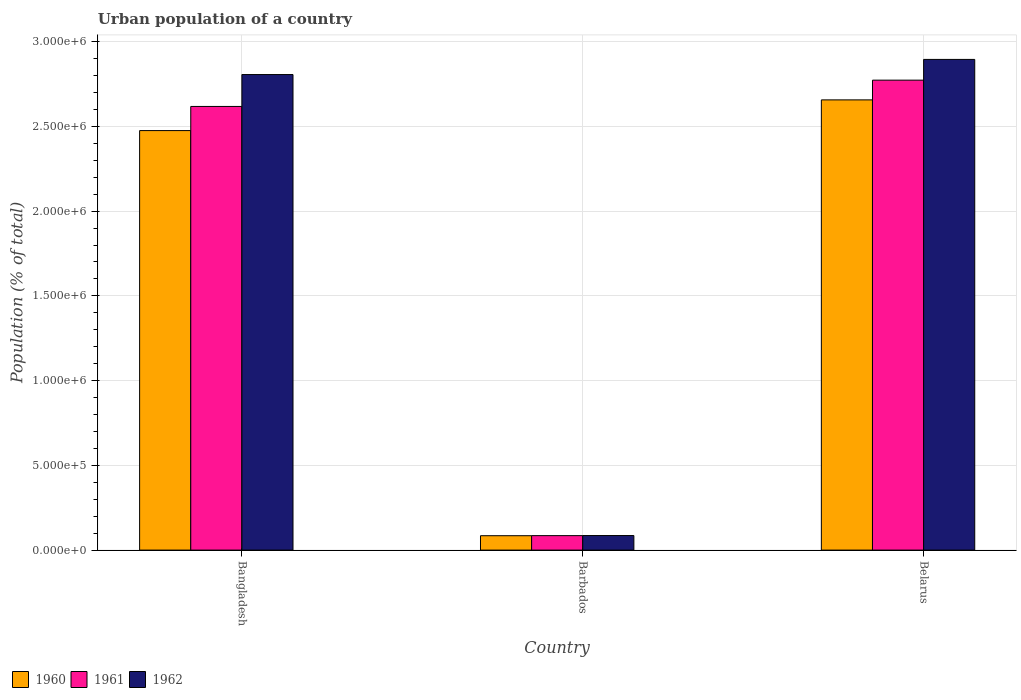How many different coloured bars are there?
Keep it short and to the point. 3. How many groups of bars are there?
Offer a very short reply. 3. Are the number of bars per tick equal to the number of legend labels?
Offer a terse response. Yes. How many bars are there on the 2nd tick from the right?
Provide a short and direct response. 3. What is the label of the 2nd group of bars from the left?
Offer a very short reply. Barbados. What is the urban population in 1961 in Belarus?
Provide a succinct answer. 2.77e+06. Across all countries, what is the maximum urban population in 1961?
Offer a terse response. 2.77e+06. Across all countries, what is the minimum urban population in 1962?
Provide a succinct answer. 8.59e+04. In which country was the urban population in 1962 maximum?
Offer a very short reply. Belarus. In which country was the urban population in 1961 minimum?
Offer a terse response. Barbados. What is the total urban population in 1962 in the graph?
Make the answer very short. 5.79e+06. What is the difference between the urban population in 1962 in Barbados and that in Belarus?
Give a very brief answer. -2.81e+06. What is the difference between the urban population in 1960 in Barbados and the urban population in 1961 in Belarus?
Your answer should be very brief. -2.69e+06. What is the average urban population in 1961 per country?
Provide a short and direct response. 1.83e+06. What is the difference between the urban population of/in 1961 and urban population of/in 1962 in Belarus?
Keep it short and to the point. -1.22e+05. In how many countries, is the urban population in 1962 greater than 500000 %?
Keep it short and to the point. 2. What is the ratio of the urban population in 1962 in Barbados to that in Belarus?
Offer a very short reply. 0.03. Is the urban population in 1960 in Barbados less than that in Belarus?
Your answer should be compact. Yes. What is the difference between the highest and the second highest urban population in 1960?
Keep it short and to the point. 2.57e+06. What is the difference between the highest and the lowest urban population in 1962?
Make the answer very short. 2.81e+06. In how many countries, is the urban population in 1962 greater than the average urban population in 1962 taken over all countries?
Make the answer very short. 2. Is the sum of the urban population in 1962 in Barbados and Belarus greater than the maximum urban population in 1960 across all countries?
Make the answer very short. Yes. What does the 2nd bar from the left in Bangladesh represents?
Provide a short and direct response. 1961. How many bars are there?
Your answer should be very brief. 9. Are all the bars in the graph horizontal?
Your response must be concise. No. How many countries are there in the graph?
Offer a very short reply. 3. Are the values on the major ticks of Y-axis written in scientific E-notation?
Make the answer very short. Yes. Does the graph contain any zero values?
Make the answer very short. No. Does the graph contain grids?
Offer a very short reply. Yes. How many legend labels are there?
Keep it short and to the point. 3. How are the legend labels stacked?
Make the answer very short. Horizontal. What is the title of the graph?
Make the answer very short. Urban population of a country. What is the label or title of the X-axis?
Your answer should be compact. Country. What is the label or title of the Y-axis?
Give a very brief answer. Population (% of total). What is the Population (% of total) in 1960 in Bangladesh?
Make the answer very short. 2.48e+06. What is the Population (% of total) in 1961 in Bangladesh?
Your response must be concise. 2.62e+06. What is the Population (% of total) of 1962 in Bangladesh?
Keep it short and to the point. 2.81e+06. What is the Population (% of total) of 1960 in Barbados?
Your response must be concise. 8.49e+04. What is the Population (% of total) of 1961 in Barbados?
Keep it short and to the point. 8.54e+04. What is the Population (% of total) of 1962 in Barbados?
Keep it short and to the point. 8.59e+04. What is the Population (% of total) of 1960 in Belarus?
Provide a short and direct response. 2.66e+06. What is the Population (% of total) in 1961 in Belarus?
Provide a succinct answer. 2.77e+06. What is the Population (% of total) in 1962 in Belarus?
Ensure brevity in your answer.  2.90e+06. Across all countries, what is the maximum Population (% of total) of 1960?
Make the answer very short. 2.66e+06. Across all countries, what is the maximum Population (% of total) in 1961?
Your response must be concise. 2.77e+06. Across all countries, what is the maximum Population (% of total) in 1962?
Offer a very short reply. 2.90e+06. Across all countries, what is the minimum Population (% of total) in 1960?
Your answer should be very brief. 8.49e+04. Across all countries, what is the minimum Population (% of total) in 1961?
Your response must be concise. 8.54e+04. Across all countries, what is the minimum Population (% of total) in 1962?
Give a very brief answer. 8.59e+04. What is the total Population (% of total) of 1960 in the graph?
Your answer should be very brief. 5.22e+06. What is the total Population (% of total) of 1961 in the graph?
Your response must be concise. 5.48e+06. What is the total Population (% of total) of 1962 in the graph?
Ensure brevity in your answer.  5.79e+06. What is the difference between the Population (% of total) in 1960 in Bangladesh and that in Barbados?
Provide a succinct answer. 2.39e+06. What is the difference between the Population (% of total) in 1961 in Bangladesh and that in Barbados?
Give a very brief answer. 2.53e+06. What is the difference between the Population (% of total) in 1962 in Bangladesh and that in Barbados?
Provide a succinct answer. 2.72e+06. What is the difference between the Population (% of total) of 1960 in Bangladesh and that in Belarus?
Keep it short and to the point. -1.81e+05. What is the difference between the Population (% of total) of 1961 in Bangladesh and that in Belarus?
Provide a succinct answer. -1.55e+05. What is the difference between the Population (% of total) of 1962 in Bangladesh and that in Belarus?
Make the answer very short. -8.94e+04. What is the difference between the Population (% of total) of 1960 in Barbados and that in Belarus?
Offer a very short reply. -2.57e+06. What is the difference between the Population (% of total) in 1961 in Barbados and that in Belarus?
Offer a terse response. -2.69e+06. What is the difference between the Population (% of total) of 1962 in Barbados and that in Belarus?
Your answer should be very brief. -2.81e+06. What is the difference between the Population (% of total) in 1960 in Bangladesh and the Population (% of total) in 1961 in Barbados?
Your answer should be very brief. 2.39e+06. What is the difference between the Population (% of total) of 1960 in Bangladesh and the Population (% of total) of 1962 in Barbados?
Give a very brief answer. 2.39e+06. What is the difference between the Population (% of total) in 1961 in Bangladesh and the Population (% of total) in 1962 in Barbados?
Offer a terse response. 2.53e+06. What is the difference between the Population (% of total) of 1960 in Bangladesh and the Population (% of total) of 1961 in Belarus?
Make the answer very short. -2.98e+05. What is the difference between the Population (% of total) of 1960 in Bangladesh and the Population (% of total) of 1962 in Belarus?
Provide a short and direct response. -4.20e+05. What is the difference between the Population (% of total) in 1961 in Bangladesh and the Population (% of total) in 1962 in Belarus?
Your answer should be compact. -2.77e+05. What is the difference between the Population (% of total) in 1960 in Barbados and the Population (% of total) in 1961 in Belarus?
Ensure brevity in your answer.  -2.69e+06. What is the difference between the Population (% of total) of 1960 in Barbados and the Population (% of total) of 1962 in Belarus?
Your response must be concise. -2.81e+06. What is the difference between the Population (% of total) in 1961 in Barbados and the Population (% of total) in 1962 in Belarus?
Provide a succinct answer. -2.81e+06. What is the average Population (% of total) in 1960 per country?
Provide a short and direct response. 1.74e+06. What is the average Population (% of total) in 1961 per country?
Offer a terse response. 1.83e+06. What is the average Population (% of total) in 1962 per country?
Keep it short and to the point. 1.93e+06. What is the difference between the Population (% of total) in 1960 and Population (% of total) in 1961 in Bangladesh?
Provide a succinct answer. -1.42e+05. What is the difference between the Population (% of total) in 1960 and Population (% of total) in 1962 in Bangladesh?
Your answer should be compact. -3.31e+05. What is the difference between the Population (% of total) in 1961 and Population (% of total) in 1962 in Bangladesh?
Make the answer very short. -1.88e+05. What is the difference between the Population (% of total) of 1960 and Population (% of total) of 1961 in Barbados?
Provide a succinct answer. -439. What is the difference between the Population (% of total) in 1960 and Population (% of total) in 1962 in Barbados?
Your response must be concise. -944. What is the difference between the Population (% of total) of 1961 and Population (% of total) of 1962 in Barbados?
Offer a very short reply. -505. What is the difference between the Population (% of total) of 1960 and Population (% of total) of 1961 in Belarus?
Make the answer very short. -1.16e+05. What is the difference between the Population (% of total) of 1960 and Population (% of total) of 1962 in Belarus?
Give a very brief answer. -2.39e+05. What is the difference between the Population (% of total) of 1961 and Population (% of total) of 1962 in Belarus?
Provide a short and direct response. -1.22e+05. What is the ratio of the Population (% of total) of 1960 in Bangladesh to that in Barbados?
Offer a very short reply. 29.14. What is the ratio of the Population (% of total) in 1961 in Bangladesh to that in Barbados?
Ensure brevity in your answer.  30.66. What is the ratio of the Population (% of total) of 1962 in Bangladesh to that in Barbados?
Offer a very short reply. 32.67. What is the ratio of the Population (% of total) of 1960 in Bangladesh to that in Belarus?
Your answer should be very brief. 0.93. What is the ratio of the Population (% of total) in 1961 in Bangladesh to that in Belarus?
Keep it short and to the point. 0.94. What is the ratio of the Population (% of total) in 1962 in Bangladesh to that in Belarus?
Offer a terse response. 0.97. What is the ratio of the Population (% of total) in 1960 in Barbados to that in Belarus?
Provide a succinct answer. 0.03. What is the ratio of the Population (% of total) of 1961 in Barbados to that in Belarus?
Make the answer very short. 0.03. What is the ratio of the Population (% of total) of 1962 in Barbados to that in Belarus?
Your answer should be very brief. 0.03. What is the difference between the highest and the second highest Population (% of total) of 1960?
Your response must be concise. 1.81e+05. What is the difference between the highest and the second highest Population (% of total) of 1961?
Provide a short and direct response. 1.55e+05. What is the difference between the highest and the second highest Population (% of total) of 1962?
Make the answer very short. 8.94e+04. What is the difference between the highest and the lowest Population (% of total) in 1960?
Your answer should be very brief. 2.57e+06. What is the difference between the highest and the lowest Population (% of total) in 1961?
Provide a succinct answer. 2.69e+06. What is the difference between the highest and the lowest Population (% of total) in 1962?
Offer a terse response. 2.81e+06. 